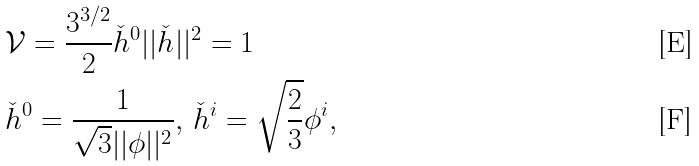<formula> <loc_0><loc_0><loc_500><loc_500>& \mathcal { V } = \frac { 3 ^ { 3 / 2 } } { 2 } \check { h } ^ { 0 } | | \check { h } | | ^ { 2 } = 1 \\ & \check { h } ^ { 0 } = \frac { 1 } { \sqrt { 3 } | | \phi | | ^ { 2 } } , \, \check { h } ^ { i } = \sqrt { \frac { 2 } { 3 } } \phi ^ { i } ,</formula> 